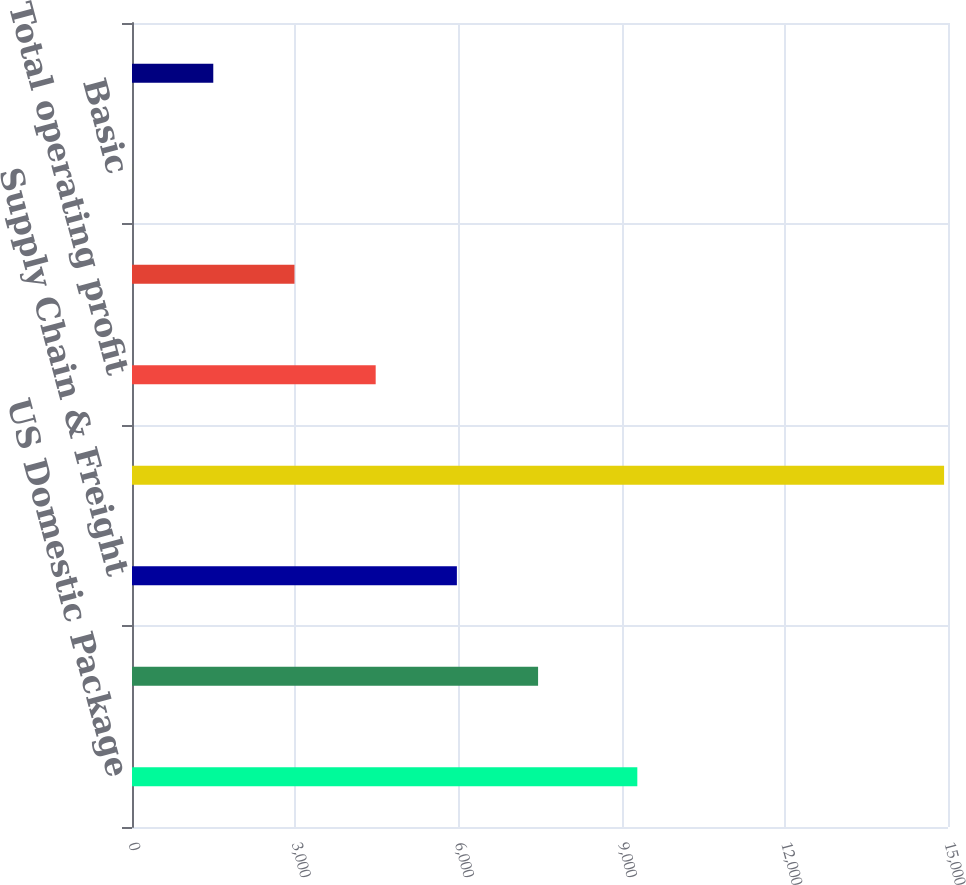Convert chart to OTSL. <chart><loc_0><loc_0><loc_500><loc_500><bar_chart><fcel>US Domestic Package<fcel>International Package<fcel>Supply Chain & Freight<fcel>Total revenue<fcel>Total operating profit<fcel>Net Income<fcel>Basic<fcel>Diluted<nl><fcel>9289<fcel>7464.74<fcel>5972.08<fcel>14928<fcel>4479.42<fcel>2986.76<fcel>1.44<fcel>1494.1<nl></chart> 